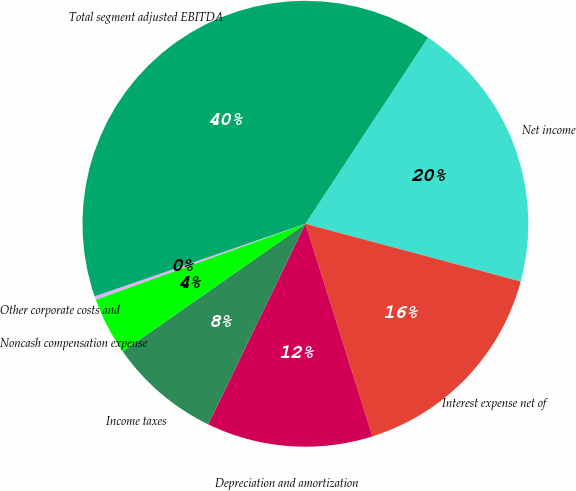<chart> <loc_0><loc_0><loc_500><loc_500><pie_chart><fcel>Net income<fcel>Interest expense net of<fcel>Depreciation and amortization<fcel>Income taxes<fcel>Noncash compensation expense<fcel>Other corporate costs and<fcel>Total segment adjusted EBITDA<nl><fcel>19.9%<fcel>15.97%<fcel>12.04%<fcel>8.11%<fcel>4.18%<fcel>0.25%<fcel>39.54%<nl></chart> 